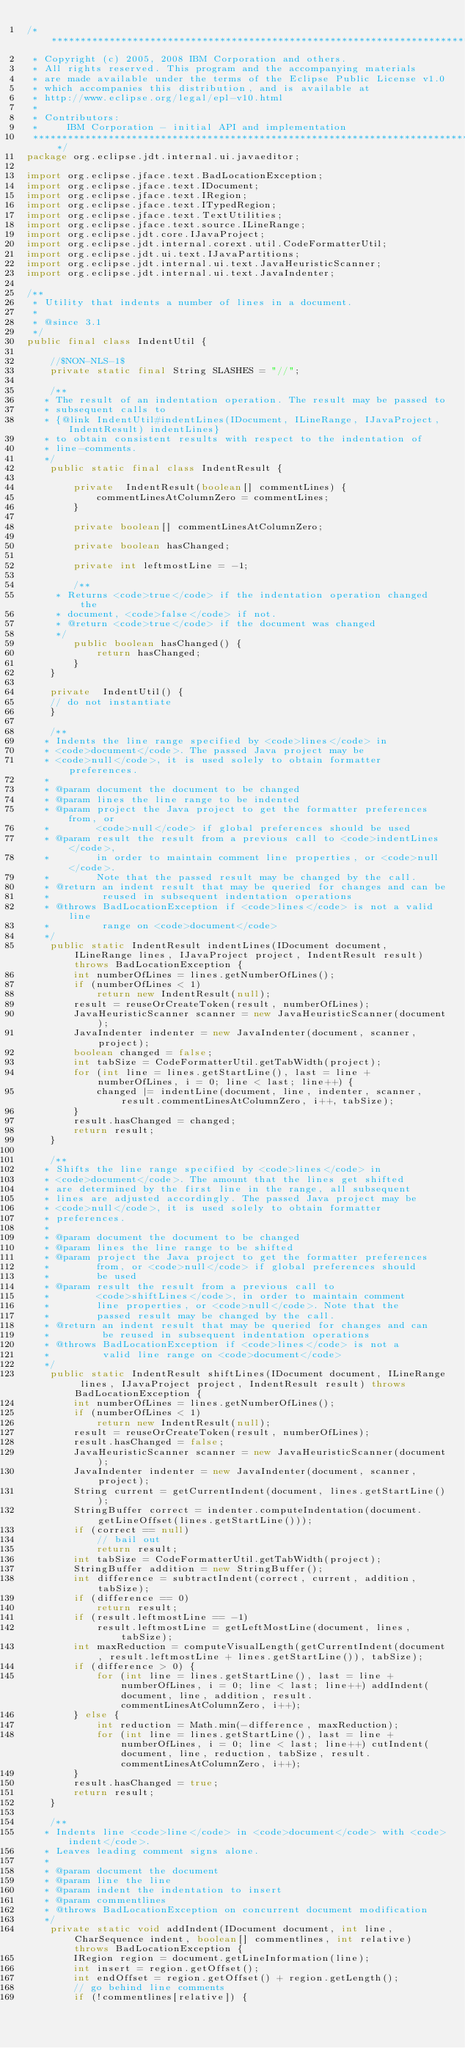<code> <loc_0><loc_0><loc_500><loc_500><_Java_>/*******************************************************************************
 * Copyright (c) 2005, 2008 IBM Corporation and others.
 * All rights reserved. This program and the accompanying materials
 * are made available under the terms of the Eclipse Public License v1.0
 * which accompanies this distribution, and is available at
 * http://www.eclipse.org/legal/epl-v10.html
 *
 * Contributors:
 *     IBM Corporation - initial API and implementation
 *******************************************************************************/
package org.eclipse.jdt.internal.ui.javaeditor;

import org.eclipse.jface.text.BadLocationException;
import org.eclipse.jface.text.IDocument;
import org.eclipse.jface.text.IRegion;
import org.eclipse.jface.text.ITypedRegion;
import org.eclipse.jface.text.TextUtilities;
import org.eclipse.jface.text.source.ILineRange;
import org.eclipse.jdt.core.IJavaProject;
import org.eclipse.jdt.internal.corext.util.CodeFormatterUtil;
import org.eclipse.jdt.ui.text.IJavaPartitions;
import org.eclipse.jdt.internal.ui.text.JavaHeuristicScanner;
import org.eclipse.jdt.internal.ui.text.JavaIndenter;

/**
 * Utility that indents a number of lines in a document.
 *
 * @since 3.1
 */
public final class IndentUtil {

    //$NON-NLS-1$
    private static final String SLASHES = "//";

    /**
	 * The result of an indentation operation. The result may be passed to
	 * subsequent calls to
	 * {@link IndentUtil#indentLines(IDocument, ILineRange, IJavaProject, IndentResult) indentLines}
	 * to obtain consistent results with respect to the indentation of
	 * line-comments.
	 */
    public static final class IndentResult {

        private  IndentResult(boolean[] commentLines) {
            commentLinesAtColumnZero = commentLines;
        }

        private boolean[] commentLinesAtColumnZero;

        private boolean hasChanged;

        private int leftmostLine = -1;

        /**
		 * Returns <code>true</code> if the indentation operation changed the
		 * document, <code>false</code> if not.
		 * @return <code>true</code> if the document was changed
		 */
        public boolean hasChanged() {
            return hasChanged;
        }
    }

    private  IndentUtil() {
    // do not instantiate
    }

    /**
	 * Indents the line range specified by <code>lines</code> in
	 * <code>document</code>. The passed Java project may be
	 * <code>null</code>, it is used solely to obtain formatter preferences.
	 *
	 * @param document the document to be changed
	 * @param lines the line range to be indented
	 * @param project the Java project to get the formatter preferences from, or
	 *        <code>null</code> if global preferences should be used
	 * @param result the result from a previous call to <code>indentLines</code>,
	 *        in order to maintain comment line properties, or <code>null</code>.
	 *        Note that the passed result may be changed by the call.
	 * @return an indent result that may be queried for changes and can be
	 *         reused in subsequent indentation operations
	 * @throws BadLocationException if <code>lines</code> is not a valid line
	 *         range on <code>document</code>
	 */
    public static IndentResult indentLines(IDocument document, ILineRange lines, IJavaProject project, IndentResult result) throws BadLocationException {
        int numberOfLines = lines.getNumberOfLines();
        if (numberOfLines < 1)
            return new IndentResult(null);
        result = reuseOrCreateToken(result, numberOfLines);
        JavaHeuristicScanner scanner = new JavaHeuristicScanner(document);
        JavaIndenter indenter = new JavaIndenter(document, scanner, project);
        boolean changed = false;
        int tabSize = CodeFormatterUtil.getTabWidth(project);
        for (int line = lines.getStartLine(), last = line + numberOfLines, i = 0; line < last; line++) {
            changed |= indentLine(document, line, indenter, scanner, result.commentLinesAtColumnZero, i++, tabSize);
        }
        result.hasChanged = changed;
        return result;
    }

    /**
	 * Shifts the line range specified by <code>lines</code> in
	 * <code>document</code>. The amount that the lines get shifted
	 * are determined by the first line in the range, all subsequent
	 * lines are adjusted accordingly. The passed Java project may be
	 * <code>null</code>, it is used solely to obtain formatter
	 * preferences.
	 *
	 * @param document the document to be changed
	 * @param lines the line range to be shifted
	 * @param project the Java project to get the formatter preferences
	 *        from, or <code>null</code> if global preferences should
	 *        be used
	 * @param result the result from a previous call to
	 *        <code>shiftLines</code>, in order to maintain comment
	 *        line properties, or <code>null</code>. Note that the
	 *        passed result may be changed by the call.
	 * @return an indent result that may be queried for changes and can
	 *         be reused in subsequent indentation operations
	 * @throws BadLocationException if <code>lines</code> is not a
	 *         valid line range on <code>document</code>
	 */
    public static IndentResult shiftLines(IDocument document, ILineRange lines, IJavaProject project, IndentResult result) throws BadLocationException {
        int numberOfLines = lines.getNumberOfLines();
        if (numberOfLines < 1)
            return new IndentResult(null);
        result = reuseOrCreateToken(result, numberOfLines);
        result.hasChanged = false;
        JavaHeuristicScanner scanner = new JavaHeuristicScanner(document);
        JavaIndenter indenter = new JavaIndenter(document, scanner, project);
        String current = getCurrentIndent(document, lines.getStartLine());
        StringBuffer correct = indenter.computeIndentation(document.getLineOffset(lines.getStartLine()));
        if (correct == null)
            // bail out
            return result;
        int tabSize = CodeFormatterUtil.getTabWidth(project);
        StringBuffer addition = new StringBuffer();
        int difference = subtractIndent(correct, current, addition, tabSize);
        if (difference == 0)
            return result;
        if (result.leftmostLine == -1)
            result.leftmostLine = getLeftMostLine(document, lines, tabSize);
        int maxReduction = computeVisualLength(getCurrentIndent(document, result.leftmostLine + lines.getStartLine()), tabSize);
        if (difference > 0) {
            for (int line = lines.getStartLine(), last = line + numberOfLines, i = 0; line < last; line++) addIndent(document, line, addition, result.commentLinesAtColumnZero, i++);
        } else {
            int reduction = Math.min(-difference, maxReduction);
            for (int line = lines.getStartLine(), last = line + numberOfLines, i = 0; line < last; line++) cutIndent(document, line, reduction, tabSize, result.commentLinesAtColumnZero, i++);
        }
        result.hasChanged = true;
        return result;
    }

    /**
	 * Indents line <code>line</code> in <code>document</code> with <code>indent</code>.
	 * Leaves leading comment signs alone.
	 *
	 * @param document the document
	 * @param line the line
	 * @param indent the indentation to insert
	 * @param commentlines
	 * @throws BadLocationException on concurrent document modification
	 */
    private static void addIndent(IDocument document, int line, CharSequence indent, boolean[] commentlines, int relative) throws BadLocationException {
        IRegion region = document.getLineInformation(line);
        int insert = region.getOffset();
        int endOffset = region.getOffset() + region.getLength();
        // go behind line comments
        if (!commentlines[relative]) {</code> 